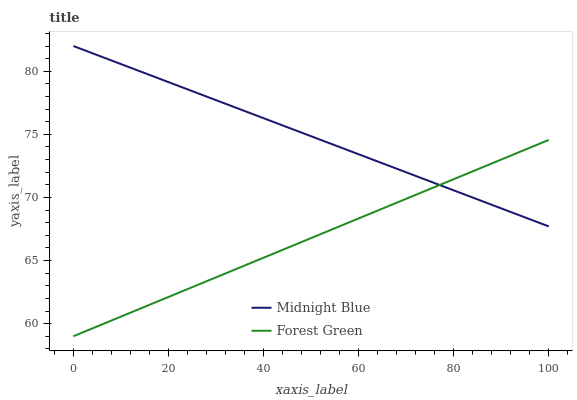Does Forest Green have the minimum area under the curve?
Answer yes or no. Yes. Does Midnight Blue have the maximum area under the curve?
Answer yes or no. Yes. Does Midnight Blue have the minimum area under the curve?
Answer yes or no. No. Is Forest Green the smoothest?
Answer yes or no. Yes. Is Midnight Blue the roughest?
Answer yes or no. Yes. Is Midnight Blue the smoothest?
Answer yes or no. No. Does Forest Green have the lowest value?
Answer yes or no. Yes. Does Midnight Blue have the lowest value?
Answer yes or no. No. Does Midnight Blue have the highest value?
Answer yes or no. Yes. Does Forest Green intersect Midnight Blue?
Answer yes or no. Yes. Is Forest Green less than Midnight Blue?
Answer yes or no. No. Is Forest Green greater than Midnight Blue?
Answer yes or no. No. 